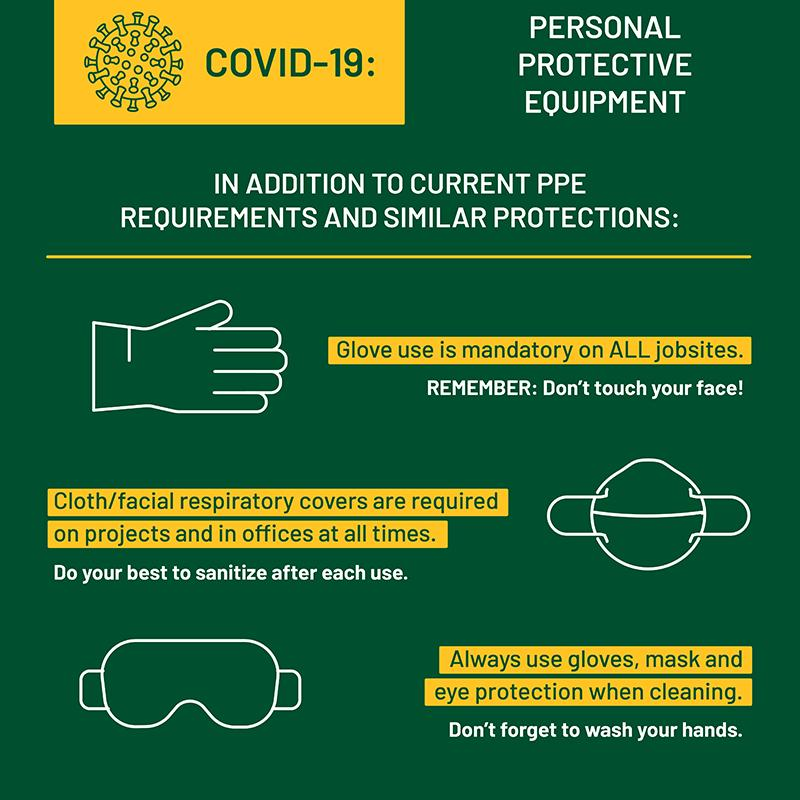List a handful of essential elements in this visual. In addition to the current personal protective equipment, gloves, masks, and eye protection will also be used as protective wear. 